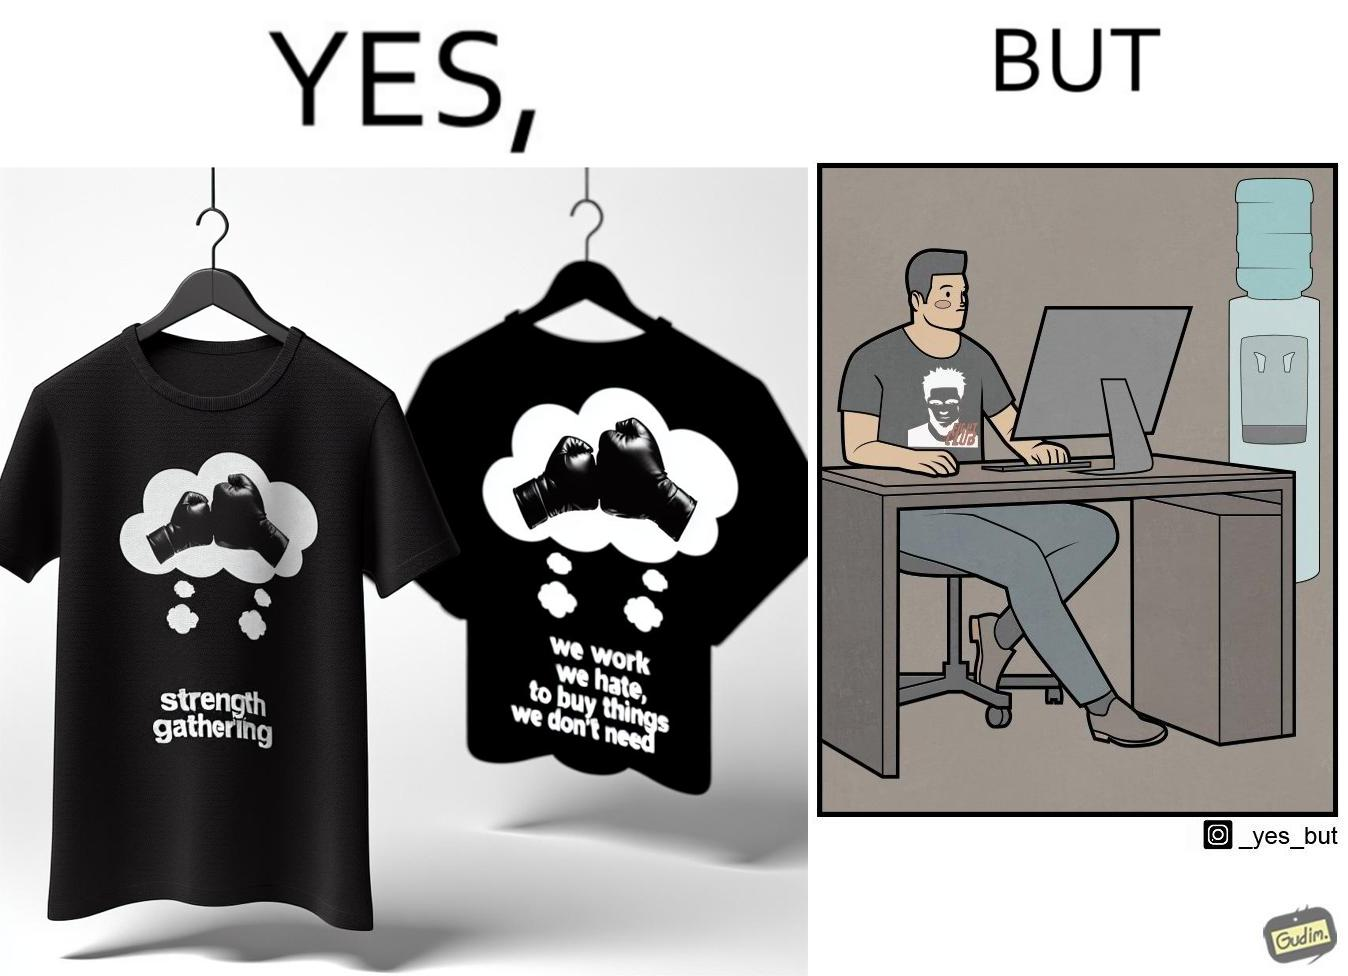Describe the satirical element in this image. The image is ironical, as the t-shirt says "We work jobs we hate, to buy sh*t we don't need", which is a rebellious message against the construct of office jobs. However, the person wearing the t-shirt seems to be working in an office environment. Also, the t-shirt might have been bought using the money earned via the very same job. 